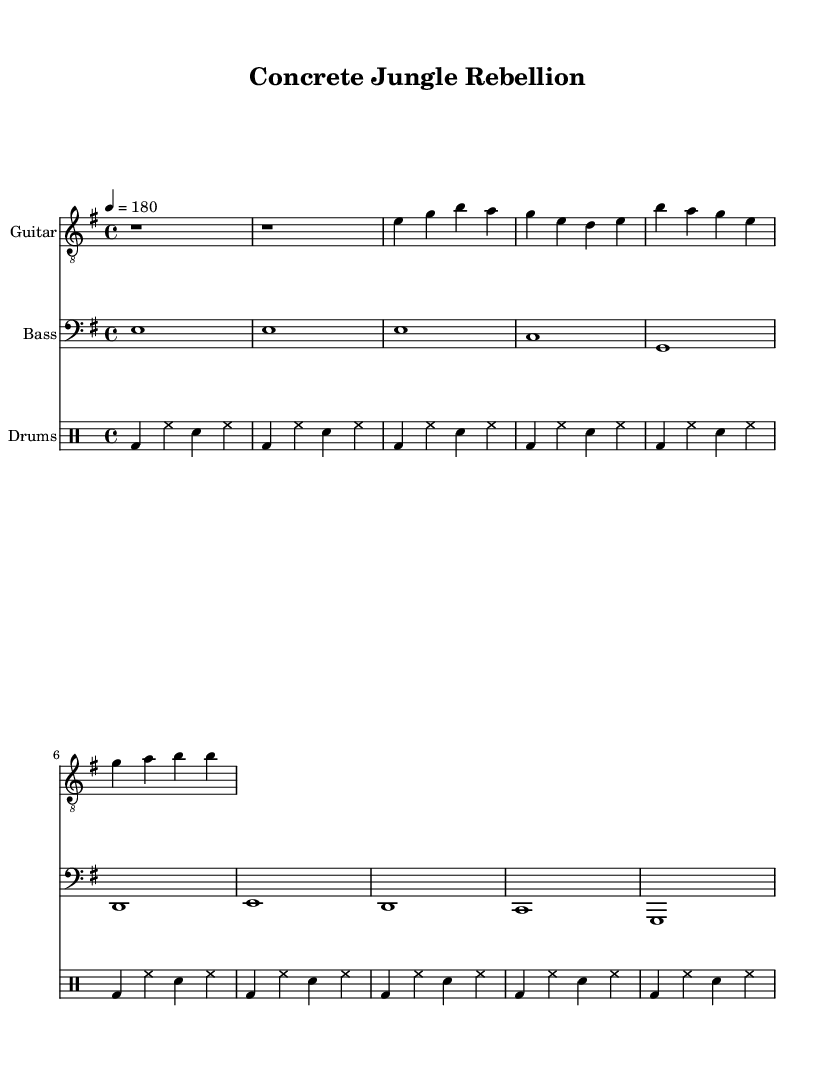What is the key signature of this music? The key signature is E minor, which contains one sharp (F#). This can be identified in the global block of the music sheet, where the key is specified.
Answer: E minor What is the time signature of this music? The time signature is 4/4 as stated in the global block of the sheet music. This indicates four beats per measure, which is a common time signature in Punk music.
Answer: 4/4 What is the tempo marking for this piece? The tempo marking is quarter note equals 180 beats per minute, which signifies that the music should be played at a fast pace. This can be noted in the global setup section.
Answer: 180 How many measures are in the verse section? The verse section contains four measures. This can be counted in the guitarMusic and bassMusic sections, as each segment has four measures dedicated to the verse.
Answer: Four What do the lyrics in the chorus reflect about punk culture? The lyrics in the chorus reflect themes of rejection and defiance, which are common sentiments in punk culture. The lyrics express feelings of being outcasts and resisting societal norms.
Answer: Outcasts and defiance What is the main instrument featured in this piece? The main instrument featured is the guitar, as indicated at the beginning of that staff in the score layout. This aligns with the prominent role of guitars in punk music.
Answer: Guitar How do the drum patterns correspond to the energetic style of punk music? The drum patterns maintain a steady and driving beat throughout, reflecting the high energy typical of punk music. The repetitive bass drum and snare hits align with traditional punk rhythms used to create intensity.
Answer: Steady and driving 